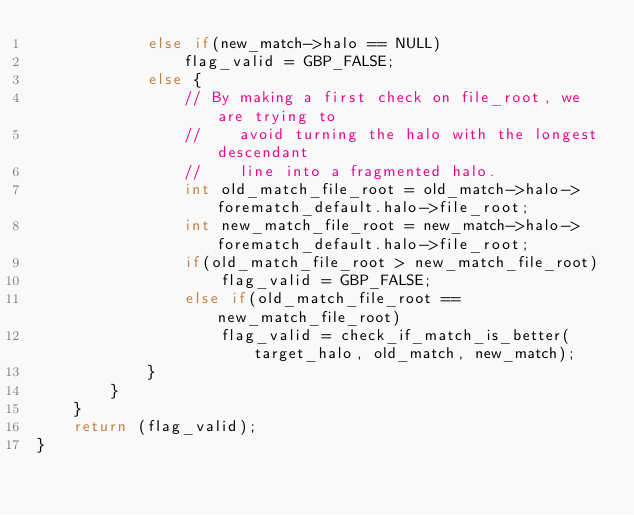<code> <loc_0><loc_0><loc_500><loc_500><_C_>            else if(new_match->halo == NULL)
                flag_valid = GBP_FALSE;
            else {
                // By making a first check on file_root, we are trying to
                //    avoid turning the halo with the longest descendant
                //    line into a fragmented halo.
                int old_match_file_root = old_match->halo->forematch_default.halo->file_root;
                int new_match_file_root = new_match->halo->forematch_default.halo->file_root;
                if(old_match_file_root > new_match_file_root)
                    flag_valid = GBP_FALSE;
                else if(old_match_file_root == new_match_file_root)
                    flag_valid = check_if_match_is_better(target_halo, old_match, new_match);
            }
        }
    }
    return (flag_valid);
}
</code> 